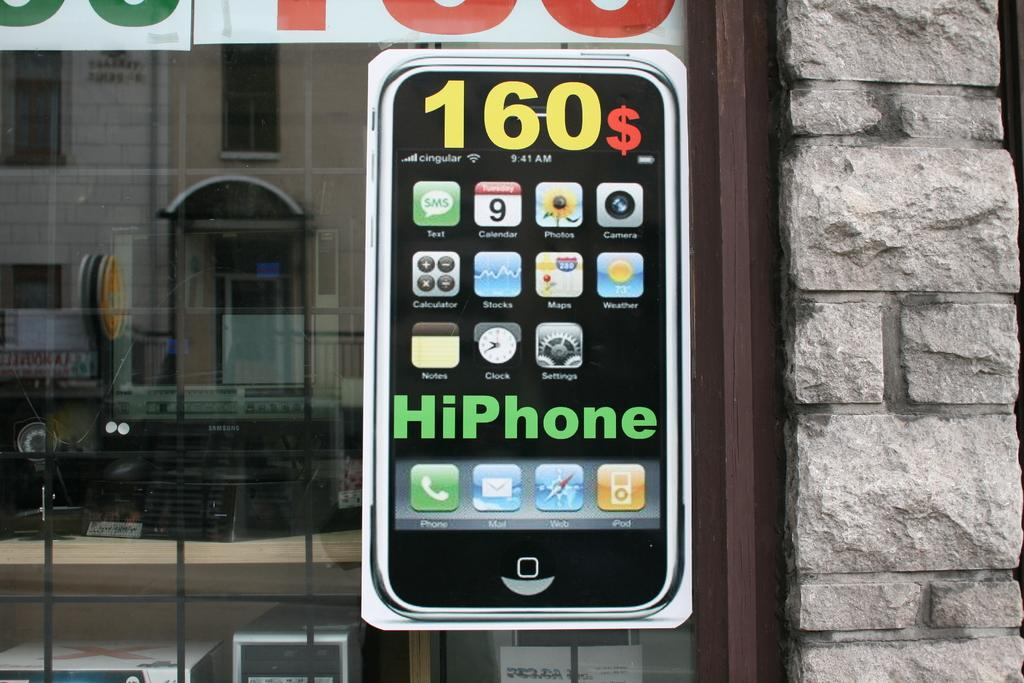<image>
Create a compact narrative representing the image presented. An advertisement on a window for a HiPhone. 